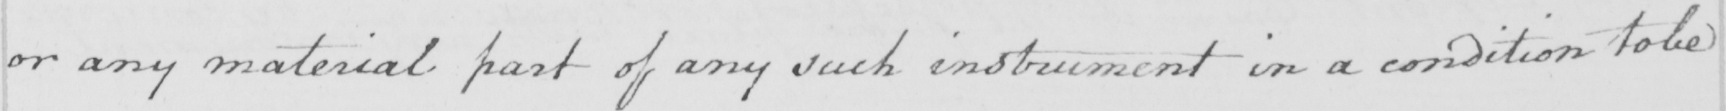Can you read and transcribe this handwriting? or any material part of any such instrument in a condition to be 